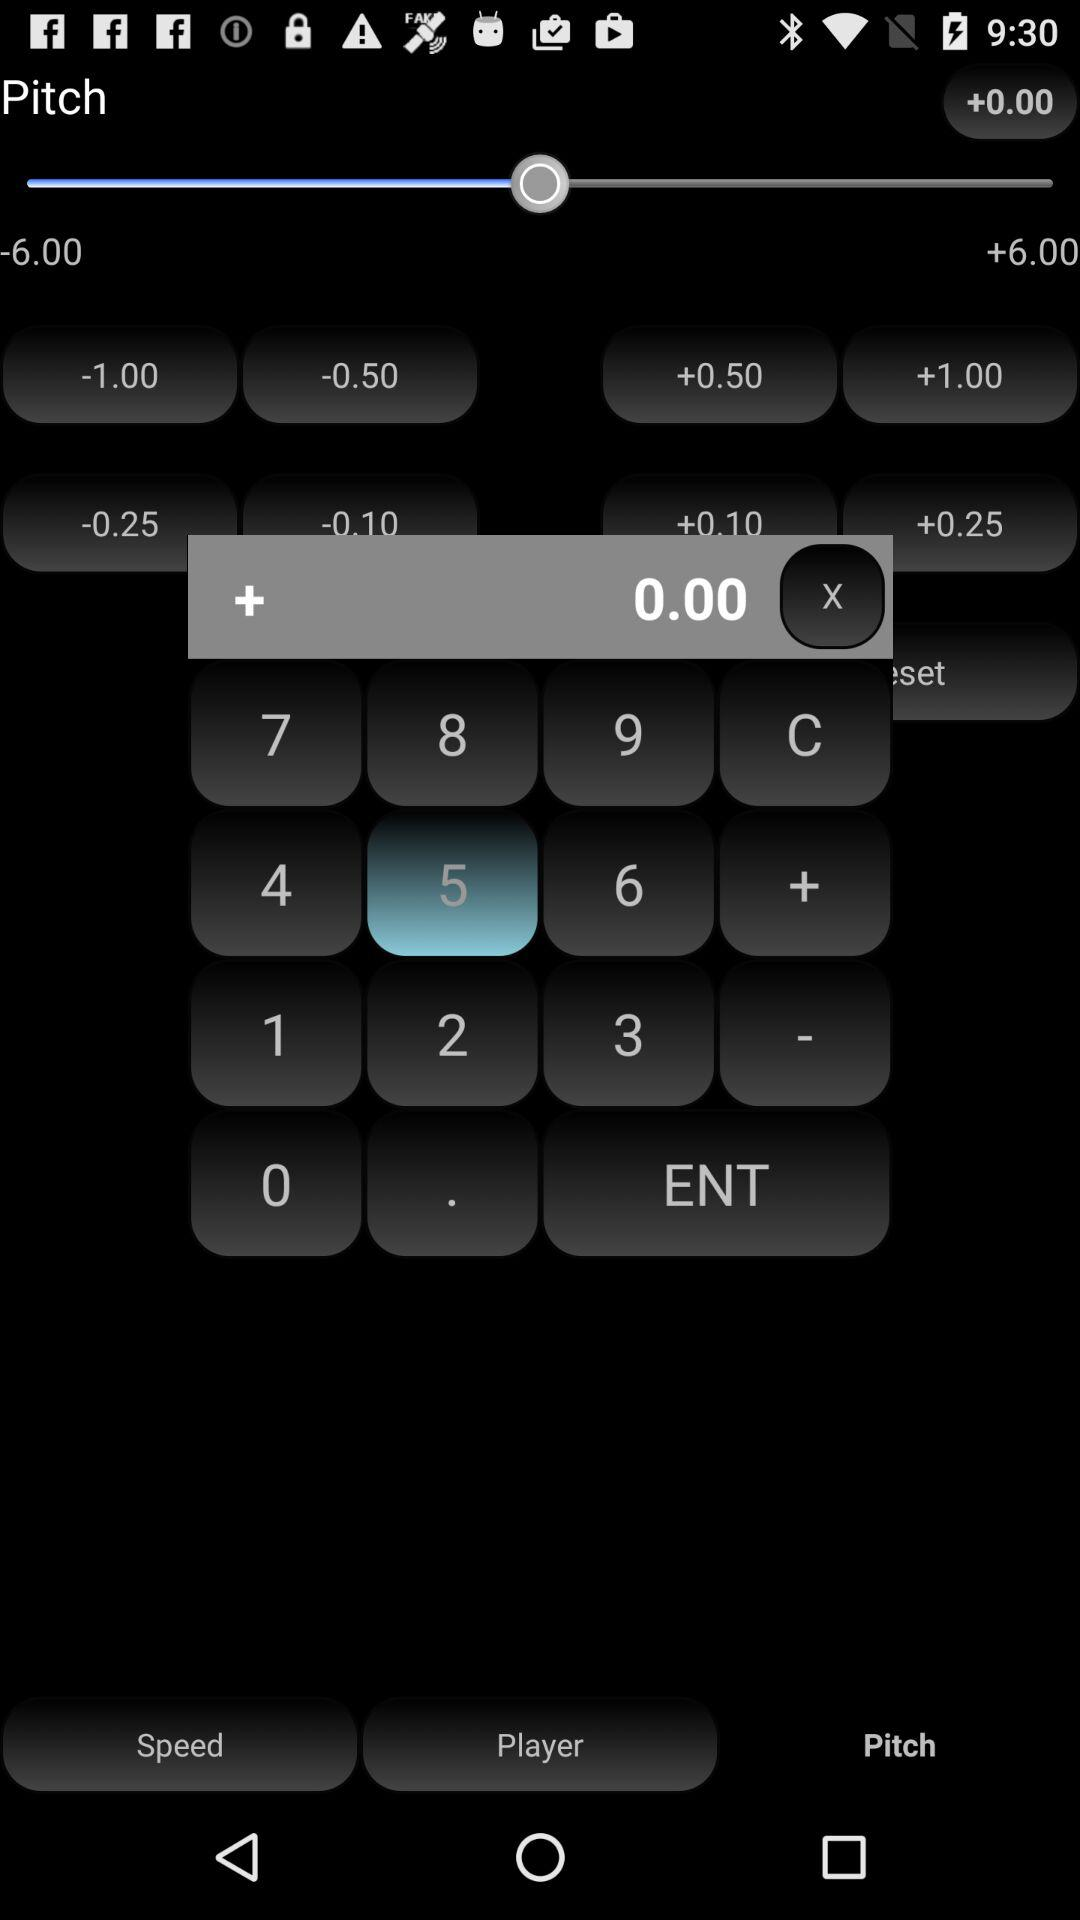What is written in the calculator type section? In the calculator type section, 0.00 is written. 